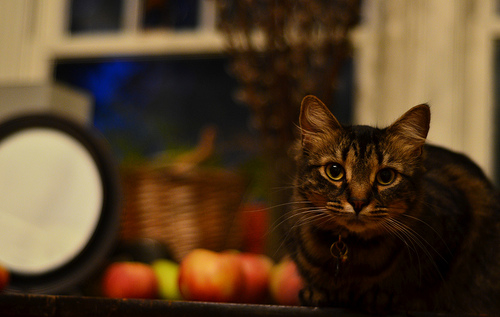<image>
Is there a cat next to the table? No. The cat is not positioned next to the table. They are located in different areas of the scene. Where is the apple in relation to the cat? Is it under the cat? No. The apple is not positioned under the cat. The vertical relationship between these objects is different. Is the apples in front of the cat? No. The apples is not in front of the cat. The spatial positioning shows a different relationship between these objects. 